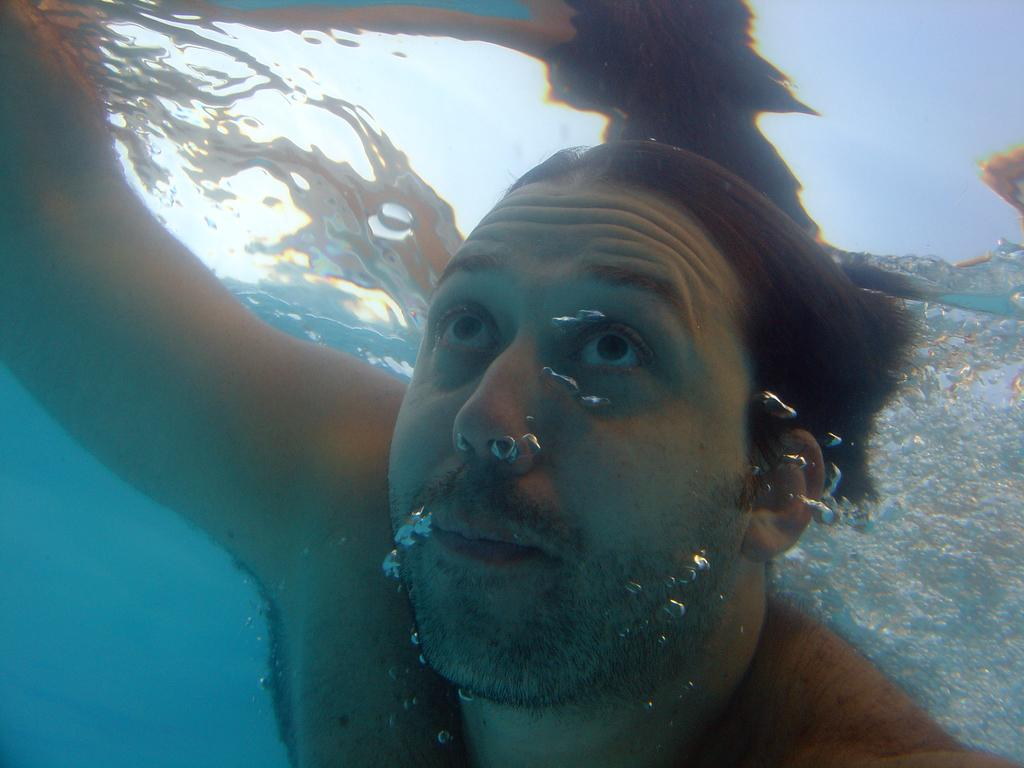What is the setting of the image? The image is taken underwater. What is the person in the image doing? There is a person diving in the water. What is the size of the calculator in the image? There is no calculator present in the image, as it is taken underwater and features a person diving. 